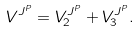Convert formula to latex. <formula><loc_0><loc_0><loc_500><loc_500>V ^ { J ^ { P } } = V ^ { J ^ { P } } _ { 2 } + V ^ { J ^ { P } } _ { 3 } .</formula> 